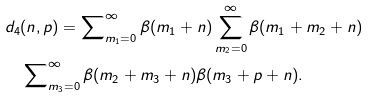Convert formula to latex. <formula><loc_0><loc_0><loc_500><loc_500>& d _ { 4 } ( n , p ) = \sum _ { m _ { 1 } = 0 } ^ { \infty } \nolimits \beta ( m _ { 1 } + n ) \sum _ { m _ { 2 } = 0 } ^ { \infty } \beta ( m _ { 1 } + m _ { 2 } + n ) \\ & \quad \sum _ { m _ { 3 } = 0 } ^ { \infty } \nolimits \beta ( m _ { 2 } + m _ { 3 } + n ) \beta ( m _ { 3 } + p + n ) .</formula> 